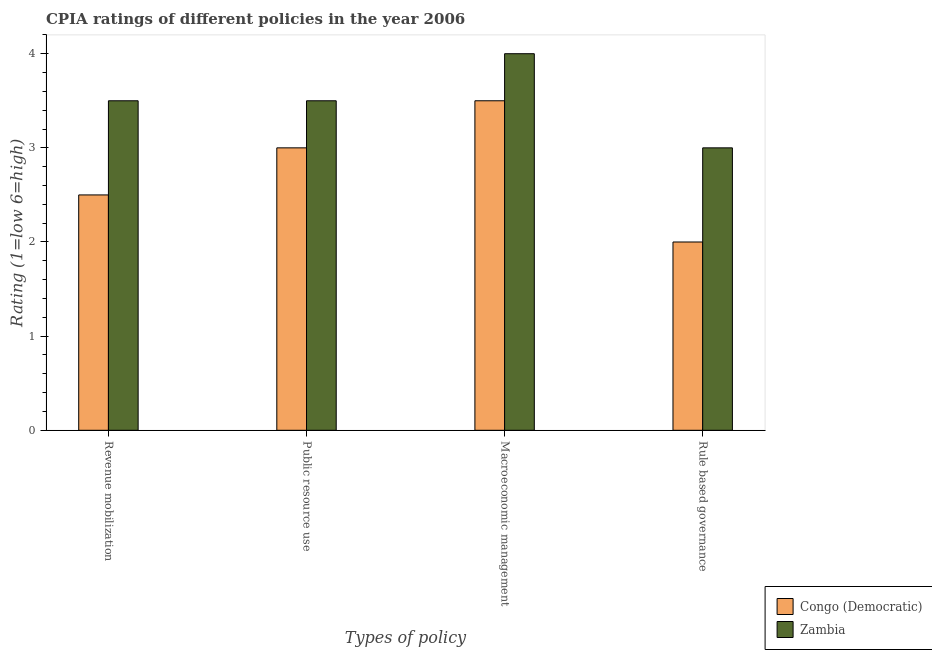How many different coloured bars are there?
Your answer should be compact. 2. How many groups of bars are there?
Make the answer very short. 4. How many bars are there on the 1st tick from the left?
Your answer should be compact. 2. How many bars are there on the 4th tick from the right?
Your answer should be compact. 2. What is the label of the 4th group of bars from the left?
Make the answer very short. Rule based governance. What is the cpia rating of rule based governance in Congo (Democratic)?
Provide a succinct answer. 2. In which country was the cpia rating of macroeconomic management maximum?
Keep it short and to the point. Zambia. In which country was the cpia rating of public resource use minimum?
Your answer should be very brief. Congo (Democratic). What is the total cpia rating of public resource use in the graph?
Your answer should be compact. 6.5. What is the average cpia rating of public resource use per country?
Your answer should be compact. 3.25. In how many countries, is the cpia rating of revenue mobilization greater than 0.8 ?
Offer a very short reply. 2. What is the ratio of the cpia rating of revenue mobilization in Congo (Democratic) to that in Zambia?
Your response must be concise. 0.71. Is the difference between the cpia rating of revenue mobilization in Congo (Democratic) and Zambia greater than the difference between the cpia rating of rule based governance in Congo (Democratic) and Zambia?
Keep it short and to the point. No. In how many countries, is the cpia rating of revenue mobilization greater than the average cpia rating of revenue mobilization taken over all countries?
Offer a very short reply. 1. Is the sum of the cpia rating of public resource use in Zambia and Congo (Democratic) greater than the maximum cpia rating of macroeconomic management across all countries?
Provide a succinct answer. Yes. What does the 2nd bar from the left in Revenue mobilization represents?
Your answer should be very brief. Zambia. What does the 2nd bar from the right in Public resource use represents?
Your response must be concise. Congo (Democratic). Is it the case that in every country, the sum of the cpia rating of revenue mobilization and cpia rating of public resource use is greater than the cpia rating of macroeconomic management?
Offer a terse response. Yes. What is the difference between two consecutive major ticks on the Y-axis?
Provide a short and direct response. 1. Are the values on the major ticks of Y-axis written in scientific E-notation?
Give a very brief answer. No. Does the graph contain any zero values?
Your answer should be very brief. No. Does the graph contain grids?
Offer a very short reply. No. Where does the legend appear in the graph?
Offer a very short reply. Bottom right. What is the title of the graph?
Offer a terse response. CPIA ratings of different policies in the year 2006. Does "High income" appear as one of the legend labels in the graph?
Provide a succinct answer. No. What is the label or title of the X-axis?
Your answer should be compact. Types of policy. What is the label or title of the Y-axis?
Give a very brief answer. Rating (1=low 6=high). What is the Rating (1=low 6=high) in Zambia in Revenue mobilization?
Your answer should be very brief. 3.5. What is the Rating (1=low 6=high) of Congo (Democratic) in Macroeconomic management?
Give a very brief answer. 3.5. What is the Rating (1=low 6=high) in Zambia in Rule based governance?
Give a very brief answer. 3. Across all Types of policy, what is the maximum Rating (1=low 6=high) in Congo (Democratic)?
Your answer should be compact. 3.5. Across all Types of policy, what is the maximum Rating (1=low 6=high) of Zambia?
Keep it short and to the point. 4. What is the total Rating (1=low 6=high) of Congo (Democratic) in the graph?
Make the answer very short. 11. What is the difference between the Rating (1=low 6=high) of Congo (Democratic) in Revenue mobilization and that in Public resource use?
Ensure brevity in your answer.  -0.5. What is the difference between the Rating (1=low 6=high) of Zambia in Revenue mobilization and that in Public resource use?
Make the answer very short. 0. What is the difference between the Rating (1=low 6=high) of Congo (Democratic) in Revenue mobilization and that in Rule based governance?
Make the answer very short. 0.5. What is the difference between the Rating (1=low 6=high) of Zambia in Revenue mobilization and that in Rule based governance?
Your response must be concise. 0.5. What is the difference between the Rating (1=low 6=high) in Congo (Democratic) in Public resource use and that in Macroeconomic management?
Your response must be concise. -0.5. What is the difference between the Rating (1=low 6=high) of Zambia in Public resource use and that in Macroeconomic management?
Your answer should be very brief. -0.5. What is the difference between the Rating (1=low 6=high) in Congo (Democratic) in Public resource use and that in Rule based governance?
Make the answer very short. 1. What is the difference between the Rating (1=low 6=high) in Congo (Democratic) in Macroeconomic management and that in Rule based governance?
Your response must be concise. 1.5. What is the difference between the Rating (1=low 6=high) of Zambia in Macroeconomic management and that in Rule based governance?
Your answer should be very brief. 1. What is the difference between the Rating (1=low 6=high) of Congo (Democratic) in Revenue mobilization and the Rating (1=low 6=high) of Zambia in Rule based governance?
Your answer should be very brief. -0.5. What is the difference between the Rating (1=low 6=high) of Congo (Democratic) in Public resource use and the Rating (1=low 6=high) of Zambia in Rule based governance?
Offer a terse response. 0. What is the average Rating (1=low 6=high) in Congo (Democratic) per Types of policy?
Make the answer very short. 2.75. What is the average Rating (1=low 6=high) of Zambia per Types of policy?
Provide a succinct answer. 3.5. What is the difference between the Rating (1=low 6=high) in Congo (Democratic) and Rating (1=low 6=high) in Zambia in Macroeconomic management?
Offer a very short reply. -0.5. What is the ratio of the Rating (1=low 6=high) of Congo (Democratic) in Revenue mobilization to that in Public resource use?
Provide a succinct answer. 0.83. What is the ratio of the Rating (1=low 6=high) in Zambia in Revenue mobilization to that in Public resource use?
Your response must be concise. 1. What is the ratio of the Rating (1=low 6=high) of Congo (Democratic) in Revenue mobilization to that in Macroeconomic management?
Your answer should be very brief. 0.71. What is the ratio of the Rating (1=low 6=high) of Zambia in Revenue mobilization to that in Macroeconomic management?
Ensure brevity in your answer.  0.88. What is the ratio of the Rating (1=low 6=high) of Congo (Democratic) in Revenue mobilization to that in Rule based governance?
Give a very brief answer. 1.25. What is the ratio of the Rating (1=low 6=high) in Zambia in Revenue mobilization to that in Rule based governance?
Ensure brevity in your answer.  1.17. What is the ratio of the Rating (1=low 6=high) in Zambia in Public resource use to that in Macroeconomic management?
Ensure brevity in your answer.  0.88. What is the ratio of the Rating (1=low 6=high) of Congo (Democratic) in Public resource use to that in Rule based governance?
Offer a very short reply. 1.5. What is the difference between the highest and the second highest Rating (1=low 6=high) of Congo (Democratic)?
Ensure brevity in your answer.  0.5. What is the difference between the highest and the second highest Rating (1=low 6=high) in Zambia?
Your response must be concise. 0.5. What is the difference between the highest and the lowest Rating (1=low 6=high) in Zambia?
Your answer should be very brief. 1. 